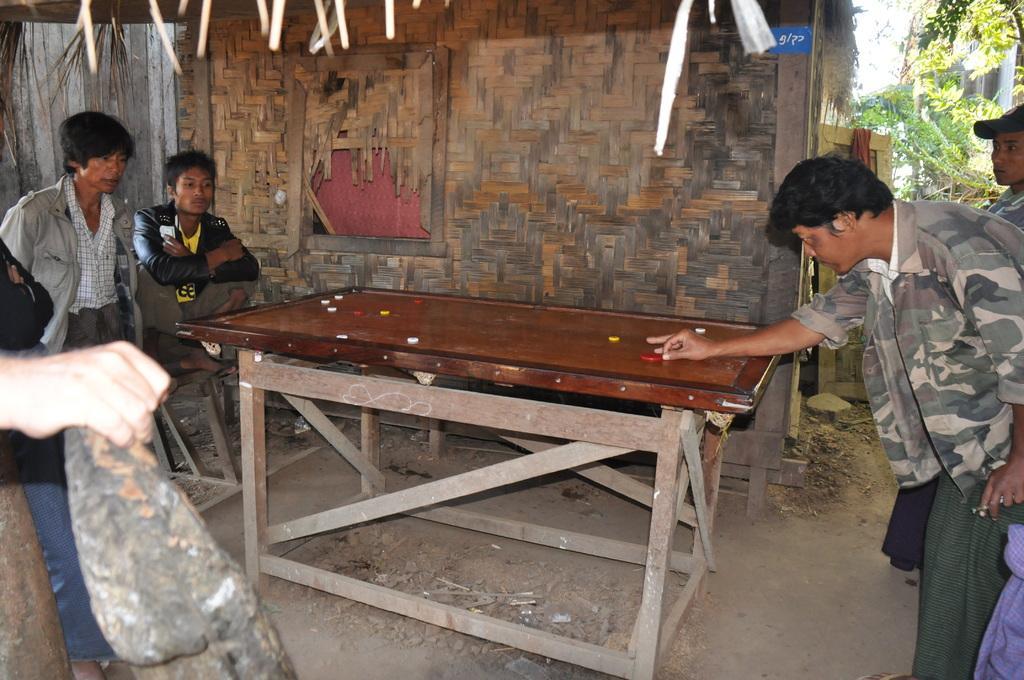Can you describe this image briefly? In this picture we can see some people playing caroms hear the person wore jacket and hitting the coin and here two persons sitting and watching them and in background we can see hut, trees. 